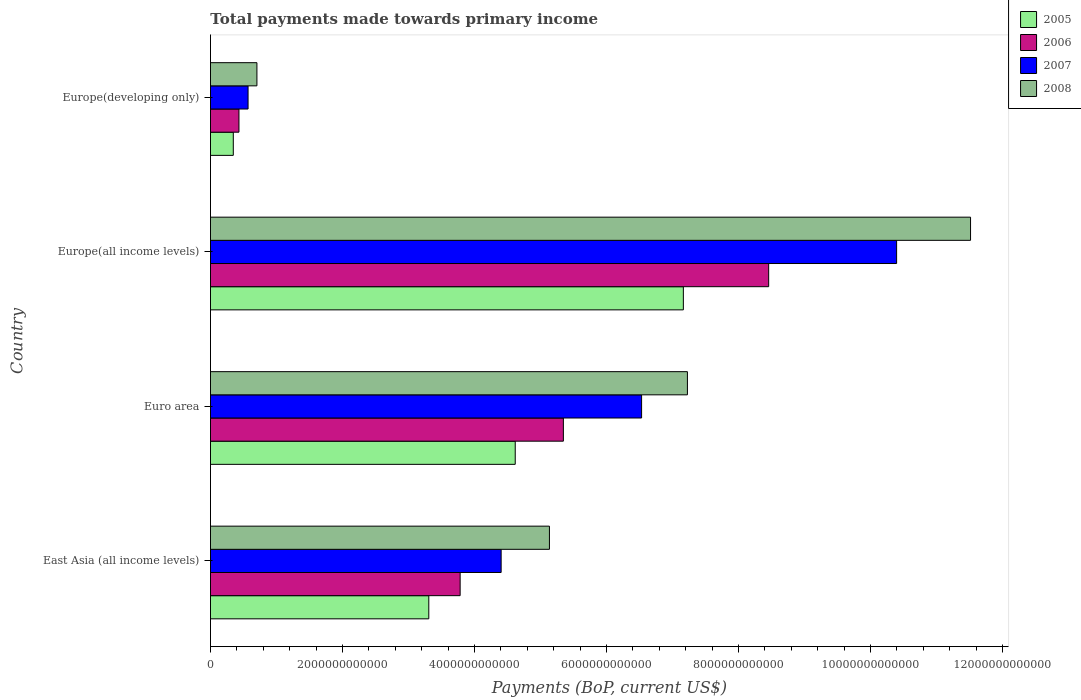Are the number of bars per tick equal to the number of legend labels?
Your answer should be compact. Yes. Are the number of bars on each tick of the Y-axis equal?
Your response must be concise. Yes. How many bars are there on the 1st tick from the top?
Your answer should be compact. 4. How many bars are there on the 3rd tick from the bottom?
Your answer should be compact. 4. What is the label of the 1st group of bars from the top?
Offer a very short reply. Europe(developing only). What is the total payments made towards primary income in 2005 in Europe(all income levels)?
Offer a very short reply. 7.16e+12. Across all countries, what is the maximum total payments made towards primary income in 2006?
Your answer should be compact. 8.46e+12. Across all countries, what is the minimum total payments made towards primary income in 2006?
Offer a terse response. 4.32e+11. In which country was the total payments made towards primary income in 2008 maximum?
Keep it short and to the point. Europe(all income levels). In which country was the total payments made towards primary income in 2005 minimum?
Make the answer very short. Europe(developing only). What is the total total payments made towards primary income in 2005 in the graph?
Provide a short and direct response. 1.54e+13. What is the difference between the total payments made towards primary income in 2008 in East Asia (all income levels) and that in Europe(all income levels)?
Ensure brevity in your answer.  -6.38e+12. What is the difference between the total payments made towards primary income in 2007 in Euro area and the total payments made towards primary income in 2008 in Europe(developing only)?
Make the answer very short. 5.83e+12. What is the average total payments made towards primary income in 2007 per country?
Provide a short and direct response. 5.48e+12. What is the difference between the total payments made towards primary income in 2007 and total payments made towards primary income in 2008 in Europe(developing only)?
Offer a terse response. -1.34e+11. What is the ratio of the total payments made towards primary income in 2005 in East Asia (all income levels) to that in Europe(all income levels)?
Offer a very short reply. 0.46. Is the total payments made towards primary income in 2006 in East Asia (all income levels) less than that in Euro area?
Offer a very short reply. Yes. What is the difference between the highest and the second highest total payments made towards primary income in 2007?
Give a very brief answer. 3.86e+12. What is the difference between the highest and the lowest total payments made towards primary income in 2005?
Give a very brief answer. 6.82e+12. In how many countries, is the total payments made towards primary income in 2005 greater than the average total payments made towards primary income in 2005 taken over all countries?
Offer a terse response. 2. Is the sum of the total payments made towards primary income in 2006 in East Asia (all income levels) and Europe(developing only) greater than the maximum total payments made towards primary income in 2008 across all countries?
Your answer should be compact. No. What does the 4th bar from the top in Europe(developing only) represents?
Your response must be concise. 2005. How many bars are there?
Make the answer very short. 16. What is the difference between two consecutive major ticks on the X-axis?
Your answer should be compact. 2.00e+12. Are the values on the major ticks of X-axis written in scientific E-notation?
Offer a terse response. No. Where does the legend appear in the graph?
Provide a succinct answer. Top right. What is the title of the graph?
Provide a succinct answer. Total payments made towards primary income. Does "1994" appear as one of the legend labels in the graph?
Provide a succinct answer. No. What is the label or title of the X-axis?
Provide a short and direct response. Payments (BoP, current US$). What is the label or title of the Y-axis?
Your answer should be compact. Country. What is the Payments (BoP, current US$) of 2005 in East Asia (all income levels)?
Your response must be concise. 3.31e+12. What is the Payments (BoP, current US$) in 2006 in East Asia (all income levels)?
Provide a short and direct response. 3.78e+12. What is the Payments (BoP, current US$) of 2007 in East Asia (all income levels)?
Ensure brevity in your answer.  4.40e+12. What is the Payments (BoP, current US$) of 2008 in East Asia (all income levels)?
Offer a terse response. 5.14e+12. What is the Payments (BoP, current US$) of 2005 in Euro area?
Your answer should be very brief. 4.62e+12. What is the Payments (BoP, current US$) in 2006 in Euro area?
Your answer should be compact. 5.35e+12. What is the Payments (BoP, current US$) in 2007 in Euro area?
Ensure brevity in your answer.  6.53e+12. What is the Payments (BoP, current US$) of 2008 in Euro area?
Your answer should be very brief. 7.23e+12. What is the Payments (BoP, current US$) of 2005 in Europe(all income levels)?
Give a very brief answer. 7.16e+12. What is the Payments (BoP, current US$) in 2006 in Europe(all income levels)?
Provide a succinct answer. 8.46e+12. What is the Payments (BoP, current US$) in 2007 in Europe(all income levels)?
Provide a short and direct response. 1.04e+13. What is the Payments (BoP, current US$) of 2008 in Europe(all income levels)?
Your response must be concise. 1.15e+13. What is the Payments (BoP, current US$) in 2005 in Europe(developing only)?
Your answer should be very brief. 3.46e+11. What is the Payments (BoP, current US$) of 2006 in Europe(developing only)?
Your answer should be very brief. 4.32e+11. What is the Payments (BoP, current US$) of 2007 in Europe(developing only)?
Your answer should be very brief. 5.70e+11. What is the Payments (BoP, current US$) in 2008 in Europe(developing only)?
Give a very brief answer. 7.04e+11. Across all countries, what is the maximum Payments (BoP, current US$) of 2005?
Make the answer very short. 7.16e+12. Across all countries, what is the maximum Payments (BoP, current US$) in 2006?
Your answer should be compact. 8.46e+12. Across all countries, what is the maximum Payments (BoP, current US$) in 2007?
Ensure brevity in your answer.  1.04e+13. Across all countries, what is the maximum Payments (BoP, current US$) of 2008?
Your response must be concise. 1.15e+13. Across all countries, what is the minimum Payments (BoP, current US$) of 2005?
Provide a short and direct response. 3.46e+11. Across all countries, what is the minimum Payments (BoP, current US$) in 2006?
Make the answer very short. 4.32e+11. Across all countries, what is the minimum Payments (BoP, current US$) of 2007?
Give a very brief answer. 5.70e+11. Across all countries, what is the minimum Payments (BoP, current US$) in 2008?
Your answer should be compact. 7.04e+11. What is the total Payments (BoP, current US$) of 2005 in the graph?
Offer a very short reply. 1.54e+13. What is the total Payments (BoP, current US$) in 2006 in the graph?
Your answer should be very brief. 1.80e+13. What is the total Payments (BoP, current US$) in 2007 in the graph?
Provide a succinct answer. 2.19e+13. What is the total Payments (BoP, current US$) in 2008 in the graph?
Your response must be concise. 2.46e+13. What is the difference between the Payments (BoP, current US$) of 2005 in East Asia (all income levels) and that in Euro area?
Offer a terse response. -1.31e+12. What is the difference between the Payments (BoP, current US$) of 2006 in East Asia (all income levels) and that in Euro area?
Your answer should be compact. -1.56e+12. What is the difference between the Payments (BoP, current US$) in 2007 in East Asia (all income levels) and that in Euro area?
Give a very brief answer. -2.13e+12. What is the difference between the Payments (BoP, current US$) in 2008 in East Asia (all income levels) and that in Euro area?
Make the answer very short. -2.09e+12. What is the difference between the Payments (BoP, current US$) of 2005 in East Asia (all income levels) and that in Europe(all income levels)?
Keep it short and to the point. -3.86e+12. What is the difference between the Payments (BoP, current US$) in 2006 in East Asia (all income levels) and that in Europe(all income levels)?
Your answer should be compact. -4.67e+12. What is the difference between the Payments (BoP, current US$) in 2007 in East Asia (all income levels) and that in Europe(all income levels)?
Your answer should be very brief. -5.99e+12. What is the difference between the Payments (BoP, current US$) of 2008 in East Asia (all income levels) and that in Europe(all income levels)?
Keep it short and to the point. -6.38e+12. What is the difference between the Payments (BoP, current US$) of 2005 in East Asia (all income levels) and that in Europe(developing only)?
Provide a succinct answer. 2.96e+12. What is the difference between the Payments (BoP, current US$) in 2006 in East Asia (all income levels) and that in Europe(developing only)?
Your answer should be compact. 3.35e+12. What is the difference between the Payments (BoP, current US$) of 2007 in East Asia (all income levels) and that in Europe(developing only)?
Make the answer very short. 3.83e+12. What is the difference between the Payments (BoP, current US$) of 2008 in East Asia (all income levels) and that in Europe(developing only)?
Provide a succinct answer. 4.43e+12. What is the difference between the Payments (BoP, current US$) in 2005 in Euro area and that in Europe(all income levels)?
Your answer should be compact. -2.55e+12. What is the difference between the Payments (BoP, current US$) of 2006 in Euro area and that in Europe(all income levels)?
Make the answer very short. -3.11e+12. What is the difference between the Payments (BoP, current US$) in 2007 in Euro area and that in Europe(all income levels)?
Give a very brief answer. -3.86e+12. What is the difference between the Payments (BoP, current US$) of 2008 in Euro area and that in Europe(all income levels)?
Provide a succinct answer. -4.29e+12. What is the difference between the Payments (BoP, current US$) in 2005 in Euro area and that in Europe(developing only)?
Your answer should be compact. 4.27e+12. What is the difference between the Payments (BoP, current US$) in 2006 in Euro area and that in Europe(developing only)?
Your answer should be very brief. 4.92e+12. What is the difference between the Payments (BoP, current US$) of 2007 in Euro area and that in Europe(developing only)?
Your response must be concise. 5.96e+12. What is the difference between the Payments (BoP, current US$) of 2008 in Euro area and that in Europe(developing only)?
Make the answer very short. 6.52e+12. What is the difference between the Payments (BoP, current US$) in 2005 in Europe(all income levels) and that in Europe(developing only)?
Your answer should be very brief. 6.82e+12. What is the difference between the Payments (BoP, current US$) of 2006 in Europe(all income levels) and that in Europe(developing only)?
Make the answer very short. 8.03e+12. What is the difference between the Payments (BoP, current US$) in 2007 in Europe(all income levels) and that in Europe(developing only)?
Provide a succinct answer. 9.83e+12. What is the difference between the Payments (BoP, current US$) in 2008 in Europe(all income levels) and that in Europe(developing only)?
Keep it short and to the point. 1.08e+13. What is the difference between the Payments (BoP, current US$) in 2005 in East Asia (all income levels) and the Payments (BoP, current US$) in 2006 in Euro area?
Provide a succinct answer. -2.04e+12. What is the difference between the Payments (BoP, current US$) in 2005 in East Asia (all income levels) and the Payments (BoP, current US$) in 2007 in Euro area?
Provide a short and direct response. -3.22e+12. What is the difference between the Payments (BoP, current US$) of 2005 in East Asia (all income levels) and the Payments (BoP, current US$) of 2008 in Euro area?
Offer a very short reply. -3.92e+12. What is the difference between the Payments (BoP, current US$) in 2006 in East Asia (all income levels) and the Payments (BoP, current US$) in 2007 in Euro area?
Offer a terse response. -2.75e+12. What is the difference between the Payments (BoP, current US$) of 2006 in East Asia (all income levels) and the Payments (BoP, current US$) of 2008 in Euro area?
Offer a terse response. -3.44e+12. What is the difference between the Payments (BoP, current US$) in 2007 in East Asia (all income levels) and the Payments (BoP, current US$) in 2008 in Euro area?
Your response must be concise. -2.82e+12. What is the difference between the Payments (BoP, current US$) in 2005 in East Asia (all income levels) and the Payments (BoP, current US$) in 2006 in Europe(all income levels)?
Give a very brief answer. -5.15e+12. What is the difference between the Payments (BoP, current US$) of 2005 in East Asia (all income levels) and the Payments (BoP, current US$) of 2007 in Europe(all income levels)?
Offer a very short reply. -7.09e+12. What is the difference between the Payments (BoP, current US$) of 2005 in East Asia (all income levels) and the Payments (BoP, current US$) of 2008 in Europe(all income levels)?
Ensure brevity in your answer.  -8.21e+12. What is the difference between the Payments (BoP, current US$) in 2006 in East Asia (all income levels) and the Payments (BoP, current US$) in 2007 in Europe(all income levels)?
Offer a very short reply. -6.61e+12. What is the difference between the Payments (BoP, current US$) of 2006 in East Asia (all income levels) and the Payments (BoP, current US$) of 2008 in Europe(all income levels)?
Provide a succinct answer. -7.73e+12. What is the difference between the Payments (BoP, current US$) of 2007 in East Asia (all income levels) and the Payments (BoP, current US$) of 2008 in Europe(all income levels)?
Keep it short and to the point. -7.11e+12. What is the difference between the Payments (BoP, current US$) in 2005 in East Asia (all income levels) and the Payments (BoP, current US$) in 2006 in Europe(developing only)?
Your answer should be compact. 2.88e+12. What is the difference between the Payments (BoP, current US$) of 2005 in East Asia (all income levels) and the Payments (BoP, current US$) of 2007 in Europe(developing only)?
Provide a short and direct response. 2.74e+12. What is the difference between the Payments (BoP, current US$) in 2005 in East Asia (all income levels) and the Payments (BoP, current US$) in 2008 in Europe(developing only)?
Ensure brevity in your answer.  2.60e+12. What is the difference between the Payments (BoP, current US$) of 2006 in East Asia (all income levels) and the Payments (BoP, current US$) of 2007 in Europe(developing only)?
Your response must be concise. 3.21e+12. What is the difference between the Payments (BoP, current US$) of 2006 in East Asia (all income levels) and the Payments (BoP, current US$) of 2008 in Europe(developing only)?
Offer a very short reply. 3.08e+12. What is the difference between the Payments (BoP, current US$) in 2007 in East Asia (all income levels) and the Payments (BoP, current US$) in 2008 in Europe(developing only)?
Provide a succinct answer. 3.70e+12. What is the difference between the Payments (BoP, current US$) of 2005 in Euro area and the Payments (BoP, current US$) of 2006 in Europe(all income levels)?
Provide a succinct answer. -3.84e+12. What is the difference between the Payments (BoP, current US$) in 2005 in Euro area and the Payments (BoP, current US$) in 2007 in Europe(all income levels)?
Offer a terse response. -5.78e+12. What is the difference between the Payments (BoP, current US$) of 2005 in Euro area and the Payments (BoP, current US$) of 2008 in Europe(all income levels)?
Your response must be concise. -6.90e+12. What is the difference between the Payments (BoP, current US$) of 2006 in Euro area and the Payments (BoP, current US$) of 2007 in Europe(all income levels)?
Your answer should be very brief. -5.05e+12. What is the difference between the Payments (BoP, current US$) of 2006 in Euro area and the Payments (BoP, current US$) of 2008 in Europe(all income levels)?
Make the answer very short. -6.17e+12. What is the difference between the Payments (BoP, current US$) of 2007 in Euro area and the Payments (BoP, current US$) of 2008 in Europe(all income levels)?
Provide a succinct answer. -4.98e+12. What is the difference between the Payments (BoP, current US$) of 2005 in Euro area and the Payments (BoP, current US$) of 2006 in Europe(developing only)?
Offer a terse response. 4.19e+12. What is the difference between the Payments (BoP, current US$) of 2005 in Euro area and the Payments (BoP, current US$) of 2007 in Europe(developing only)?
Ensure brevity in your answer.  4.05e+12. What is the difference between the Payments (BoP, current US$) of 2005 in Euro area and the Payments (BoP, current US$) of 2008 in Europe(developing only)?
Your answer should be very brief. 3.91e+12. What is the difference between the Payments (BoP, current US$) of 2006 in Euro area and the Payments (BoP, current US$) of 2007 in Europe(developing only)?
Your answer should be very brief. 4.78e+12. What is the difference between the Payments (BoP, current US$) in 2006 in Euro area and the Payments (BoP, current US$) in 2008 in Europe(developing only)?
Offer a terse response. 4.64e+12. What is the difference between the Payments (BoP, current US$) in 2007 in Euro area and the Payments (BoP, current US$) in 2008 in Europe(developing only)?
Keep it short and to the point. 5.83e+12. What is the difference between the Payments (BoP, current US$) in 2005 in Europe(all income levels) and the Payments (BoP, current US$) in 2006 in Europe(developing only)?
Keep it short and to the point. 6.73e+12. What is the difference between the Payments (BoP, current US$) of 2005 in Europe(all income levels) and the Payments (BoP, current US$) of 2007 in Europe(developing only)?
Offer a terse response. 6.60e+12. What is the difference between the Payments (BoP, current US$) of 2005 in Europe(all income levels) and the Payments (BoP, current US$) of 2008 in Europe(developing only)?
Your answer should be very brief. 6.46e+12. What is the difference between the Payments (BoP, current US$) of 2006 in Europe(all income levels) and the Payments (BoP, current US$) of 2007 in Europe(developing only)?
Provide a succinct answer. 7.89e+12. What is the difference between the Payments (BoP, current US$) in 2006 in Europe(all income levels) and the Payments (BoP, current US$) in 2008 in Europe(developing only)?
Offer a very short reply. 7.75e+12. What is the difference between the Payments (BoP, current US$) in 2007 in Europe(all income levels) and the Payments (BoP, current US$) in 2008 in Europe(developing only)?
Offer a very short reply. 9.69e+12. What is the average Payments (BoP, current US$) of 2005 per country?
Offer a terse response. 3.86e+12. What is the average Payments (BoP, current US$) in 2006 per country?
Offer a very short reply. 4.50e+12. What is the average Payments (BoP, current US$) of 2007 per country?
Your response must be concise. 5.48e+12. What is the average Payments (BoP, current US$) of 2008 per country?
Your answer should be very brief. 6.15e+12. What is the difference between the Payments (BoP, current US$) of 2005 and Payments (BoP, current US$) of 2006 in East Asia (all income levels)?
Your response must be concise. -4.75e+11. What is the difference between the Payments (BoP, current US$) in 2005 and Payments (BoP, current US$) in 2007 in East Asia (all income levels)?
Offer a very short reply. -1.10e+12. What is the difference between the Payments (BoP, current US$) in 2005 and Payments (BoP, current US$) in 2008 in East Asia (all income levels)?
Make the answer very short. -1.83e+12. What is the difference between the Payments (BoP, current US$) in 2006 and Payments (BoP, current US$) in 2007 in East Asia (all income levels)?
Your response must be concise. -6.21e+11. What is the difference between the Payments (BoP, current US$) in 2006 and Payments (BoP, current US$) in 2008 in East Asia (all income levels)?
Your answer should be very brief. -1.35e+12. What is the difference between the Payments (BoP, current US$) of 2007 and Payments (BoP, current US$) of 2008 in East Asia (all income levels)?
Your answer should be compact. -7.32e+11. What is the difference between the Payments (BoP, current US$) of 2005 and Payments (BoP, current US$) of 2006 in Euro area?
Make the answer very short. -7.29e+11. What is the difference between the Payments (BoP, current US$) of 2005 and Payments (BoP, current US$) of 2007 in Euro area?
Make the answer very short. -1.91e+12. What is the difference between the Payments (BoP, current US$) in 2005 and Payments (BoP, current US$) in 2008 in Euro area?
Offer a terse response. -2.61e+12. What is the difference between the Payments (BoP, current US$) in 2006 and Payments (BoP, current US$) in 2007 in Euro area?
Offer a terse response. -1.19e+12. What is the difference between the Payments (BoP, current US$) of 2006 and Payments (BoP, current US$) of 2008 in Euro area?
Your response must be concise. -1.88e+12. What is the difference between the Payments (BoP, current US$) in 2007 and Payments (BoP, current US$) in 2008 in Euro area?
Ensure brevity in your answer.  -6.94e+11. What is the difference between the Payments (BoP, current US$) in 2005 and Payments (BoP, current US$) in 2006 in Europe(all income levels)?
Your answer should be compact. -1.29e+12. What is the difference between the Payments (BoP, current US$) of 2005 and Payments (BoP, current US$) of 2007 in Europe(all income levels)?
Give a very brief answer. -3.23e+12. What is the difference between the Payments (BoP, current US$) of 2005 and Payments (BoP, current US$) of 2008 in Europe(all income levels)?
Offer a terse response. -4.35e+12. What is the difference between the Payments (BoP, current US$) in 2006 and Payments (BoP, current US$) in 2007 in Europe(all income levels)?
Keep it short and to the point. -1.94e+12. What is the difference between the Payments (BoP, current US$) in 2006 and Payments (BoP, current US$) in 2008 in Europe(all income levels)?
Offer a terse response. -3.06e+12. What is the difference between the Payments (BoP, current US$) in 2007 and Payments (BoP, current US$) in 2008 in Europe(all income levels)?
Make the answer very short. -1.12e+12. What is the difference between the Payments (BoP, current US$) of 2005 and Payments (BoP, current US$) of 2006 in Europe(developing only)?
Provide a succinct answer. -8.59e+1. What is the difference between the Payments (BoP, current US$) in 2005 and Payments (BoP, current US$) in 2007 in Europe(developing only)?
Keep it short and to the point. -2.24e+11. What is the difference between the Payments (BoP, current US$) in 2005 and Payments (BoP, current US$) in 2008 in Europe(developing only)?
Make the answer very short. -3.58e+11. What is the difference between the Payments (BoP, current US$) in 2006 and Payments (BoP, current US$) in 2007 in Europe(developing only)?
Your answer should be compact. -1.38e+11. What is the difference between the Payments (BoP, current US$) in 2006 and Payments (BoP, current US$) in 2008 in Europe(developing only)?
Keep it short and to the point. -2.72e+11. What is the difference between the Payments (BoP, current US$) of 2007 and Payments (BoP, current US$) of 2008 in Europe(developing only)?
Offer a terse response. -1.34e+11. What is the ratio of the Payments (BoP, current US$) of 2005 in East Asia (all income levels) to that in Euro area?
Your response must be concise. 0.72. What is the ratio of the Payments (BoP, current US$) in 2006 in East Asia (all income levels) to that in Euro area?
Make the answer very short. 0.71. What is the ratio of the Payments (BoP, current US$) in 2007 in East Asia (all income levels) to that in Euro area?
Keep it short and to the point. 0.67. What is the ratio of the Payments (BoP, current US$) in 2008 in East Asia (all income levels) to that in Euro area?
Your answer should be very brief. 0.71. What is the ratio of the Payments (BoP, current US$) of 2005 in East Asia (all income levels) to that in Europe(all income levels)?
Offer a terse response. 0.46. What is the ratio of the Payments (BoP, current US$) in 2006 in East Asia (all income levels) to that in Europe(all income levels)?
Ensure brevity in your answer.  0.45. What is the ratio of the Payments (BoP, current US$) of 2007 in East Asia (all income levels) to that in Europe(all income levels)?
Your answer should be very brief. 0.42. What is the ratio of the Payments (BoP, current US$) of 2008 in East Asia (all income levels) to that in Europe(all income levels)?
Make the answer very short. 0.45. What is the ratio of the Payments (BoP, current US$) in 2005 in East Asia (all income levels) to that in Europe(developing only)?
Provide a succinct answer. 9.57. What is the ratio of the Payments (BoP, current US$) in 2006 in East Asia (all income levels) to that in Europe(developing only)?
Your response must be concise. 8.76. What is the ratio of the Payments (BoP, current US$) of 2007 in East Asia (all income levels) to that in Europe(developing only)?
Your answer should be compact. 7.73. What is the ratio of the Payments (BoP, current US$) of 2008 in East Asia (all income levels) to that in Europe(developing only)?
Offer a terse response. 7.3. What is the ratio of the Payments (BoP, current US$) in 2005 in Euro area to that in Europe(all income levels)?
Your answer should be very brief. 0.64. What is the ratio of the Payments (BoP, current US$) of 2006 in Euro area to that in Europe(all income levels)?
Offer a very short reply. 0.63. What is the ratio of the Payments (BoP, current US$) of 2007 in Euro area to that in Europe(all income levels)?
Provide a short and direct response. 0.63. What is the ratio of the Payments (BoP, current US$) of 2008 in Euro area to that in Europe(all income levels)?
Your answer should be very brief. 0.63. What is the ratio of the Payments (BoP, current US$) in 2005 in Euro area to that in Europe(developing only)?
Offer a terse response. 13.36. What is the ratio of the Payments (BoP, current US$) of 2006 in Euro area to that in Europe(developing only)?
Your answer should be very brief. 12.39. What is the ratio of the Payments (BoP, current US$) of 2007 in Euro area to that in Europe(developing only)?
Provide a succinct answer. 11.47. What is the ratio of the Payments (BoP, current US$) in 2008 in Euro area to that in Europe(developing only)?
Ensure brevity in your answer.  10.27. What is the ratio of the Payments (BoP, current US$) of 2005 in Europe(all income levels) to that in Europe(developing only)?
Provide a short and direct response. 20.73. What is the ratio of the Payments (BoP, current US$) of 2006 in Europe(all income levels) to that in Europe(developing only)?
Make the answer very short. 19.59. What is the ratio of the Payments (BoP, current US$) of 2007 in Europe(all income levels) to that in Europe(developing only)?
Make the answer very short. 18.25. What is the ratio of the Payments (BoP, current US$) in 2008 in Europe(all income levels) to that in Europe(developing only)?
Your response must be concise. 16.36. What is the difference between the highest and the second highest Payments (BoP, current US$) in 2005?
Your answer should be very brief. 2.55e+12. What is the difference between the highest and the second highest Payments (BoP, current US$) of 2006?
Offer a terse response. 3.11e+12. What is the difference between the highest and the second highest Payments (BoP, current US$) of 2007?
Your response must be concise. 3.86e+12. What is the difference between the highest and the second highest Payments (BoP, current US$) in 2008?
Your answer should be compact. 4.29e+12. What is the difference between the highest and the lowest Payments (BoP, current US$) in 2005?
Keep it short and to the point. 6.82e+12. What is the difference between the highest and the lowest Payments (BoP, current US$) of 2006?
Your response must be concise. 8.03e+12. What is the difference between the highest and the lowest Payments (BoP, current US$) in 2007?
Provide a succinct answer. 9.83e+12. What is the difference between the highest and the lowest Payments (BoP, current US$) in 2008?
Ensure brevity in your answer.  1.08e+13. 